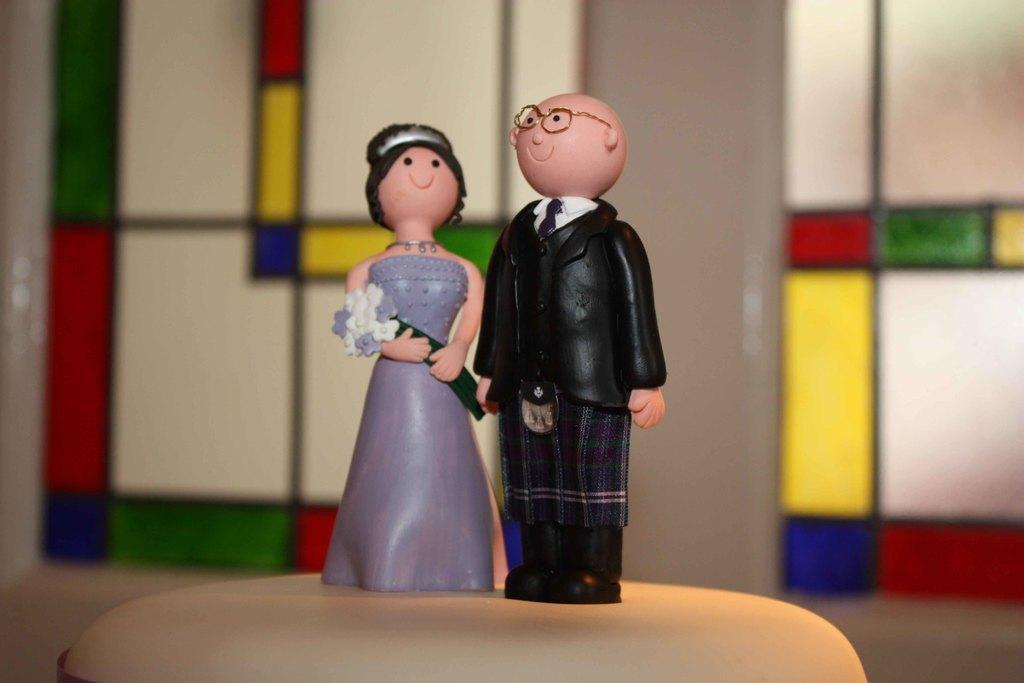How would you summarize this image in a sentence or two? There are toys of a man and a woman. Woman is holding a bouquet. In the background there is a wall. 